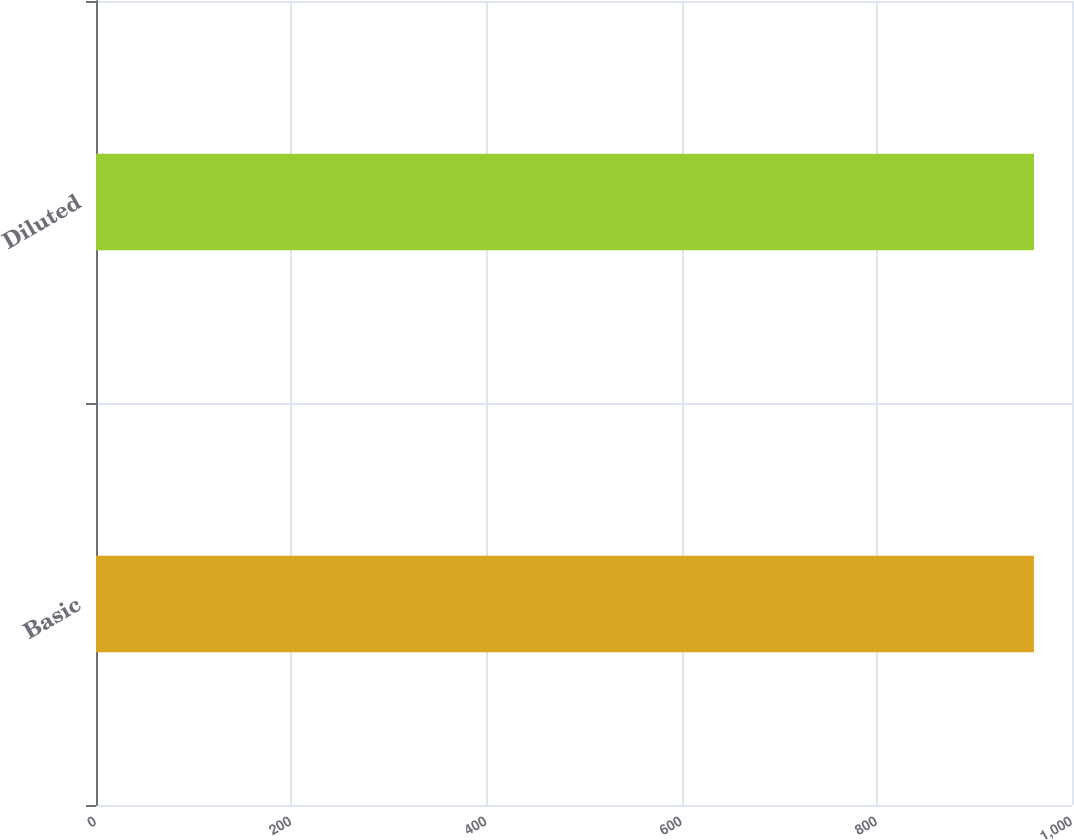Convert chart. <chart><loc_0><loc_0><loc_500><loc_500><bar_chart><fcel>Basic<fcel>Diluted<nl><fcel>961<fcel>961.1<nl></chart> 